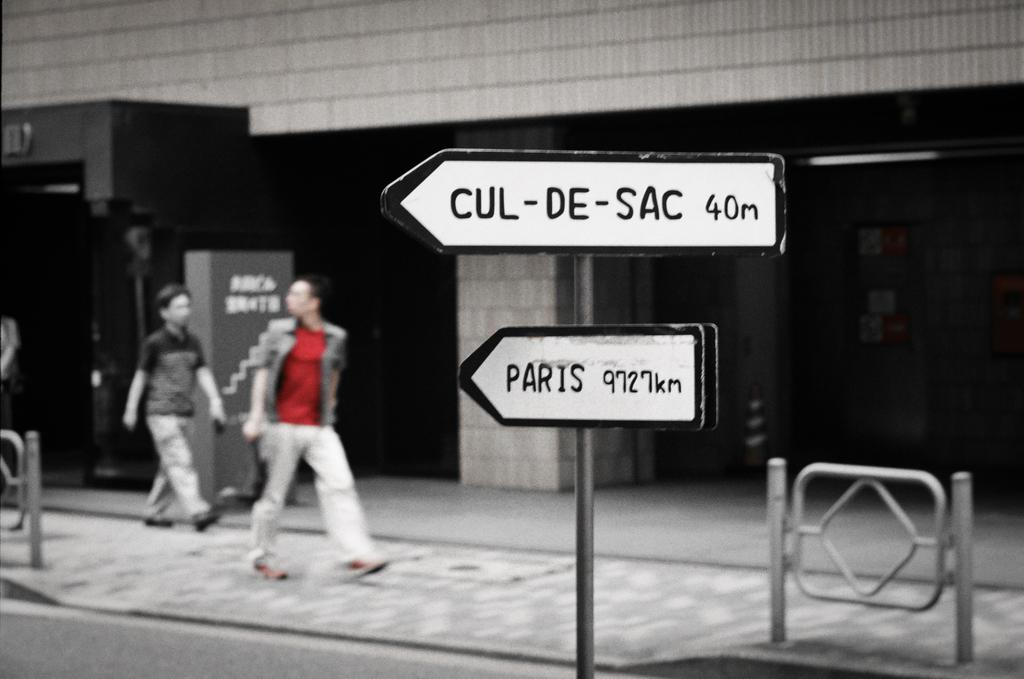What are the two people in the image doing? The two people in the image are walking. Can you describe the clothing of one of the people? One person is wearing a red and white dress. What can be seen in the background of the image? There is a building and sign boards visible in the background of the image. What type of lace can be seen on the calendar in the image? There is no calendar present in the image, so it is not possible to determine if there is any lace on it. 